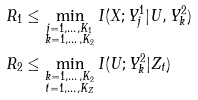<formula> <loc_0><loc_0><loc_500><loc_500>R _ { 1 } & \leq \min _ { \substack { j = 1 , \dots , K _ { 1 } \\ k = 1 , \dots , K _ { 2 } } } I ( X ; Y ^ { 1 } _ { j } | U , Y ^ { 2 } _ { k } ) \\ R _ { 2 } & \leq \min _ { \substack { k = 1 , \dots , K _ { 2 } \\ t = 1 , \dots , K _ { Z } } } I ( U ; Y ^ { 2 } _ { k } | Z _ { t } )</formula> 